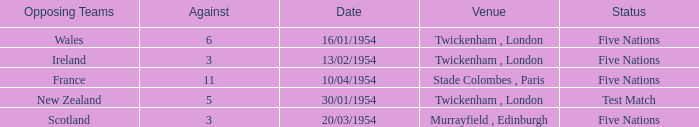What was the venue for the game played on 16/01/1954, when the against was more than 3? Twickenham , London. Could you parse the entire table? {'header': ['Opposing Teams', 'Against', 'Date', 'Venue', 'Status'], 'rows': [['Wales', '6', '16/01/1954', 'Twickenham , London', 'Five Nations'], ['Ireland', '3', '13/02/1954', 'Twickenham , London', 'Five Nations'], ['France', '11', '10/04/1954', 'Stade Colombes , Paris', 'Five Nations'], ['New Zealand', '5', '30/01/1954', 'Twickenham , London', 'Test Match'], ['Scotland', '3', '20/03/1954', 'Murrayfield , Edinburgh', 'Five Nations']]} 